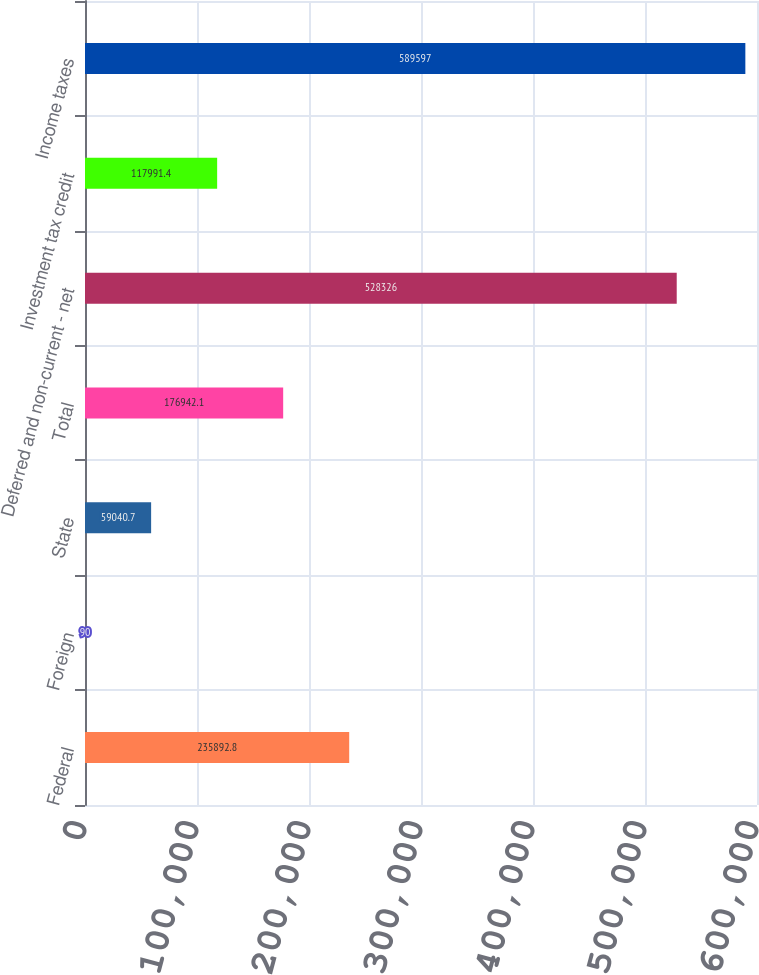Convert chart to OTSL. <chart><loc_0><loc_0><loc_500><loc_500><bar_chart><fcel>Federal<fcel>Foreign<fcel>State<fcel>Total<fcel>Deferred and non-current - net<fcel>Investment tax credit<fcel>Income taxes<nl><fcel>235893<fcel>90<fcel>59040.7<fcel>176942<fcel>528326<fcel>117991<fcel>589597<nl></chart> 